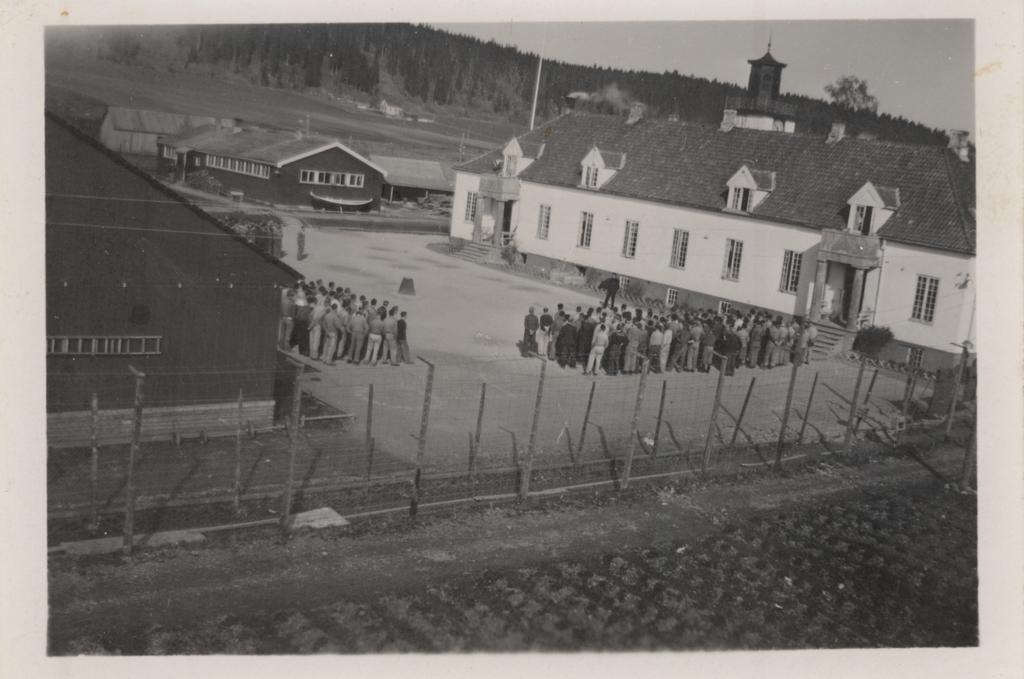What is the color scheme of the image? The image is black and white. What type of structures can be seen in the image? There are houses in the image. What else can be seen in the image besides the houses? There are groups of persons and a fencing in the image. What can be seen in the background of the image? There are trees in the background of the image. What type of rail is present in the image? There is no rail present in the image. What emotion can be seen on the faces of the persons in the image? The image is black and white, so it is difficult to determine the emotions of the persons based on their facial expressions. 